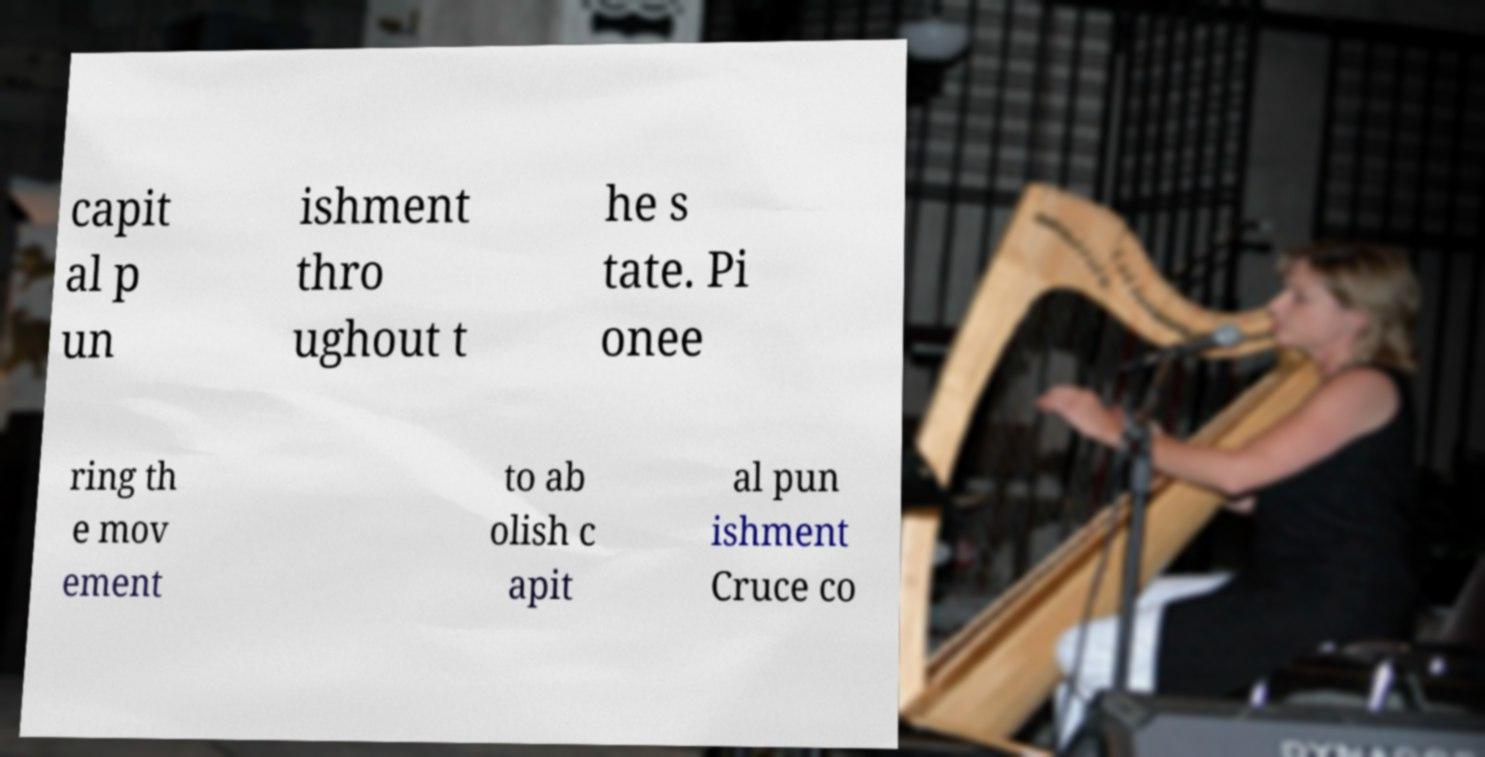Please identify and transcribe the text found in this image. capit al p un ishment thro ughout t he s tate. Pi onee ring th e mov ement to ab olish c apit al pun ishment Cruce co 